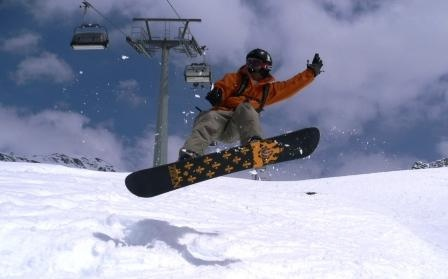Describe the objects in this image and their specific colors. I can see people in darkblue, black, maroon, and gray tones, snowboard in darkblue, black, maroon, and gray tones, bench in darkblue, gray, and black tones, and bench in darkblue, black, and gray tones in this image. 